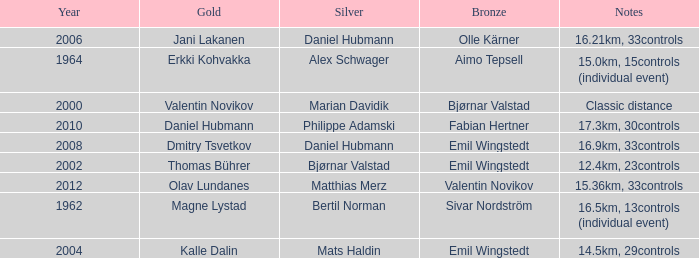WHAT YEAR HAS A SILVER FOR MATTHIAS MERZ? 2012.0. 